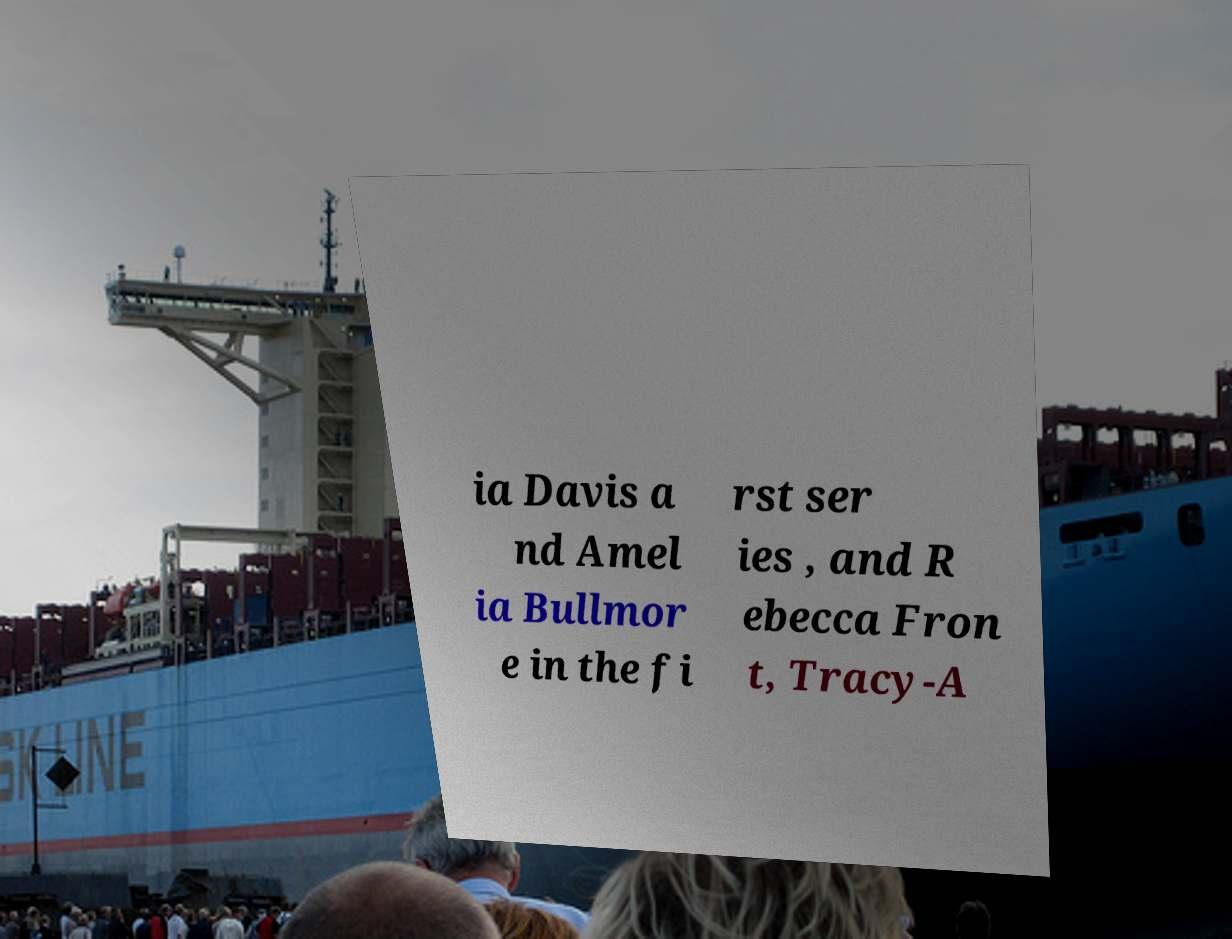Can you read and provide the text displayed in the image?This photo seems to have some interesting text. Can you extract and type it out for me? ia Davis a nd Amel ia Bullmor e in the fi rst ser ies , and R ebecca Fron t, Tracy-A 